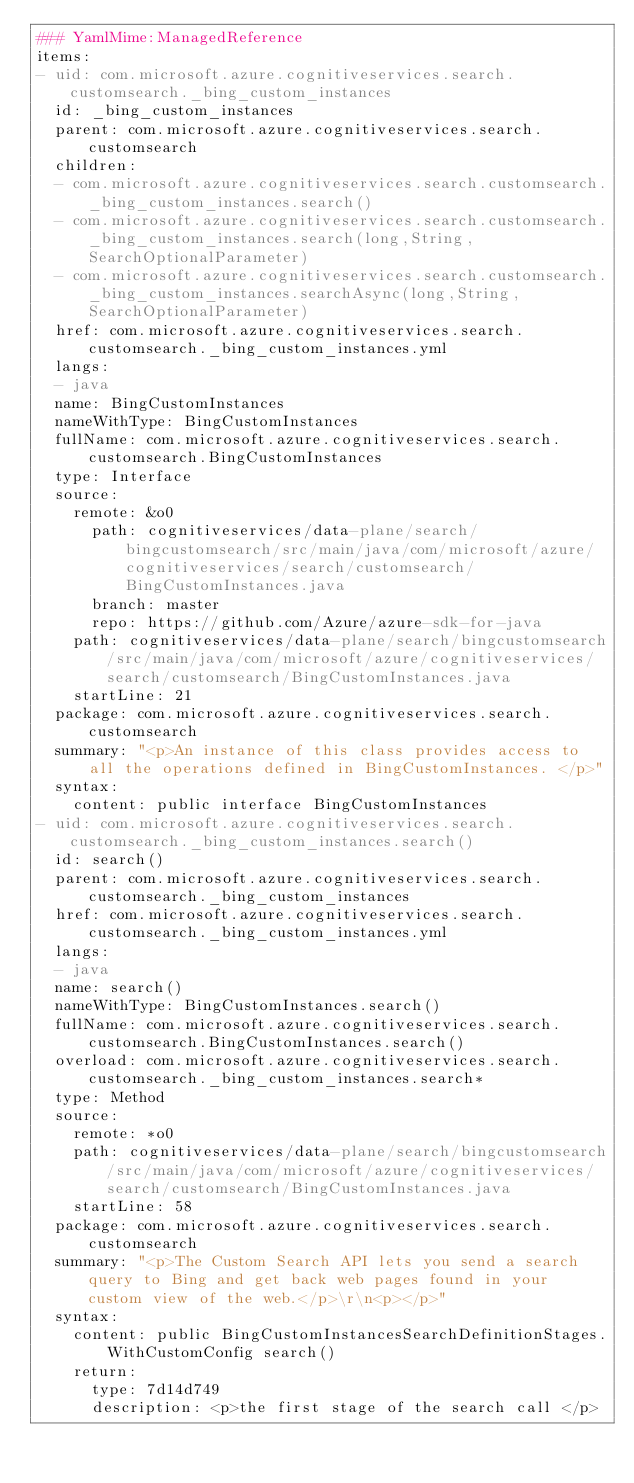Convert code to text. <code><loc_0><loc_0><loc_500><loc_500><_YAML_>### YamlMime:ManagedReference
items:
- uid: com.microsoft.azure.cognitiveservices.search.customsearch._bing_custom_instances
  id: _bing_custom_instances
  parent: com.microsoft.azure.cognitiveservices.search.customsearch
  children:
  - com.microsoft.azure.cognitiveservices.search.customsearch._bing_custom_instances.search()
  - com.microsoft.azure.cognitiveservices.search.customsearch._bing_custom_instances.search(long,String,SearchOptionalParameter)
  - com.microsoft.azure.cognitiveservices.search.customsearch._bing_custom_instances.searchAsync(long,String,SearchOptionalParameter)
  href: com.microsoft.azure.cognitiveservices.search.customsearch._bing_custom_instances.yml
  langs:
  - java
  name: BingCustomInstances
  nameWithType: BingCustomInstances
  fullName: com.microsoft.azure.cognitiveservices.search.customsearch.BingCustomInstances
  type: Interface
  source:
    remote: &o0
      path: cognitiveservices/data-plane/search/bingcustomsearch/src/main/java/com/microsoft/azure/cognitiveservices/search/customsearch/BingCustomInstances.java
      branch: master
      repo: https://github.com/Azure/azure-sdk-for-java
    path: cognitiveservices/data-plane/search/bingcustomsearch/src/main/java/com/microsoft/azure/cognitiveservices/search/customsearch/BingCustomInstances.java
    startLine: 21
  package: com.microsoft.azure.cognitiveservices.search.customsearch
  summary: "<p>An instance of this class provides access to all the operations defined in BingCustomInstances. </p>"
  syntax:
    content: public interface BingCustomInstances
- uid: com.microsoft.azure.cognitiveservices.search.customsearch._bing_custom_instances.search()
  id: search()
  parent: com.microsoft.azure.cognitiveservices.search.customsearch._bing_custom_instances
  href: com.microsoft.azure.cognitiveservices.search.customsearch._bing_custom_instances.yml
  langs:
  - java
  name: search()
  nameWithType: BingCustomInstances.search()
  fullName: com.microsoft.azure.cognitiveservices.search.customsearch.BingCustomInstances.search()
  overload: com.microsoft.azure.cognitiveservices.search.customsearch._bing_custom_instances.search*
  type: Method
  source:
    remote: *o0
    path: cognitiveservices/data-plane/search/bingcustomsearch/src/main/java/com/microsoft/azure/cognitiveservices/search/customsearch/BingCustomInstances.java
    startLine: 58
  package: com.microsoft.azure.cognitiveservices.search.customsearch
  summary: "<p>The Custom Search API lets you send a search query to Bing and get back web pages found in your custom view of the web.</p>\r\n<p></p>"
  syntax:
    content: public BingCustomInstancesSearchDefinitionStages.WithCustomConfig search()
    return:
      type: 7d14d749
      description: <p>the first stage of the search call </p></code> 